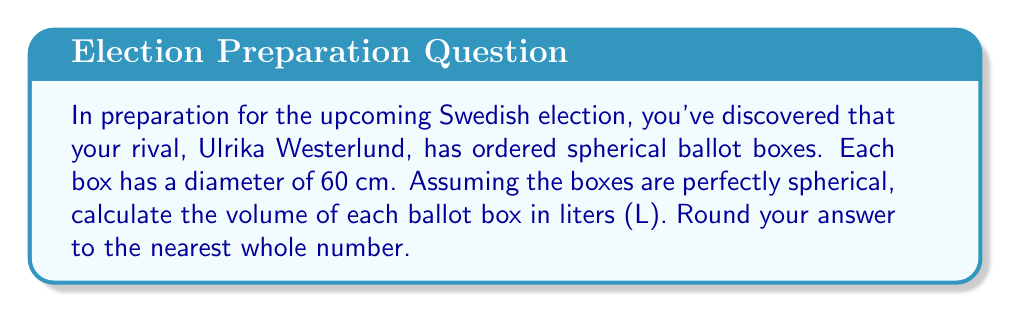Could you help me with this problem? To solve this problem, let's follow these steps:

1) The formula for the volume of a sphere is:
   $$V = \frac{4}{3}\pi r^3$$
   where $r$ is the radius of the sphere.

2) We're given the diameter, which is 60 cm. The radius is half of this:
   $$r = \frac{60}{2} = 30 \text{ cm}$$

3) Let's substitute this into our formula:
   $$V = \frac{4}{3}\pi (30\text{ cm})^3$$

4) Simplify:
   $$V = \frac{4}{3}\pi (27000\text{ cm}^3)$$
   $$V = 36000\pi\text{ cm}^3$$

5) Calculate (using $\pi \approx 3.14159$):
   $$V \approx 113097.3\text{ cm}^3$$

6) Convert to liters (1 L = 1000 cm³):
   $$V \approx 113.0973\text{ L}$$

7) Rounding to the nearest whole number:
   $$V \approx 113\text{ L}$$
Answer: 113 L 